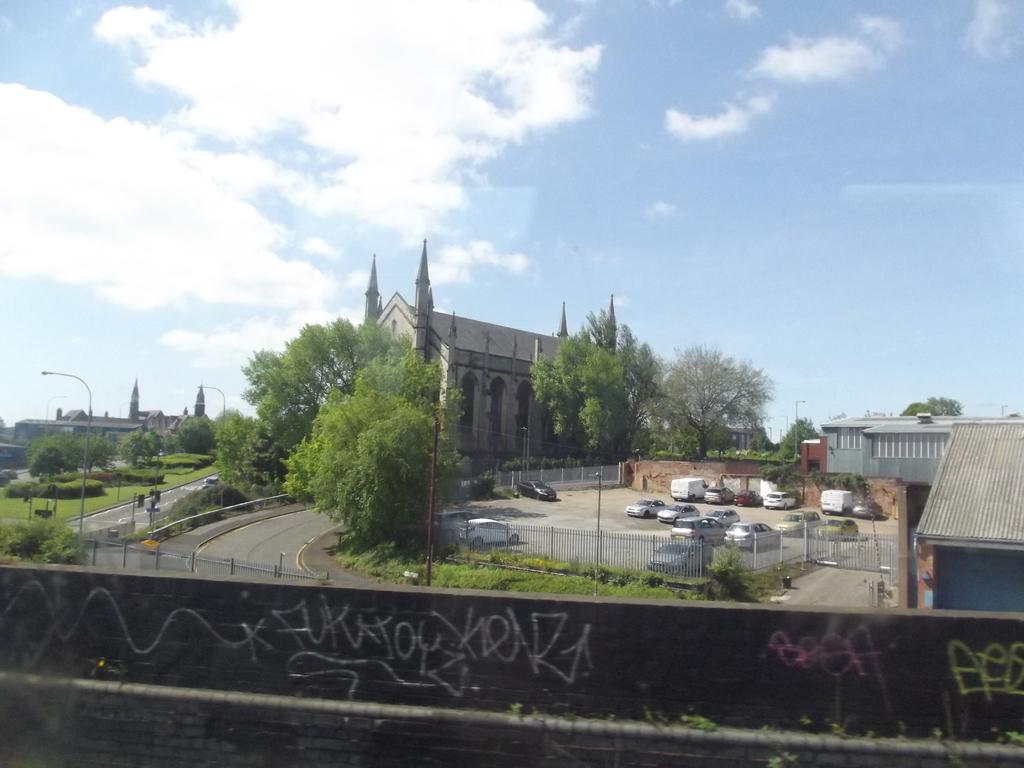<image>
Relay a brief, clear account of the picture shown. The word "beef" is written in pink spray paint on a stone wall in front of a church. 